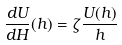Convert formula to latex. <formula><loc_0><loc_0><loc_500><loc_500>\frac { d U } { d H } ( h ) = \zeta \frac { U ( h ) } { h }</formula> 